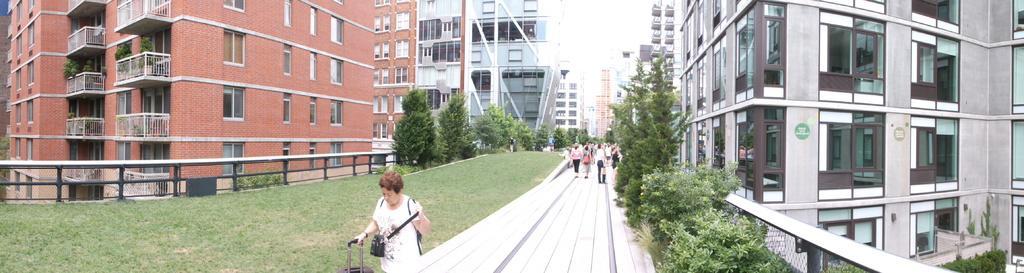How would you summarize this image in a sentence or two? On the right side of the picture there are buildings and trees. In the center of the picture there are trees, grass and people walking down the road. On the left there are buildings, plants, railing and grass. 